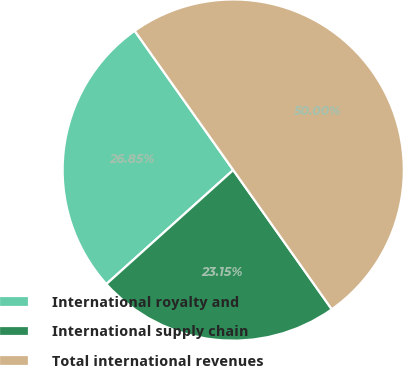<chart> <loc_0><loc_0><loc_500><loc_500><pie_chart><fcel>International royalty and<fcel>International supply chain<fcel>Total international revenues<nl><fcel>26.85%<fcel>23.15%<fcel>50.0%<nl></chart> 